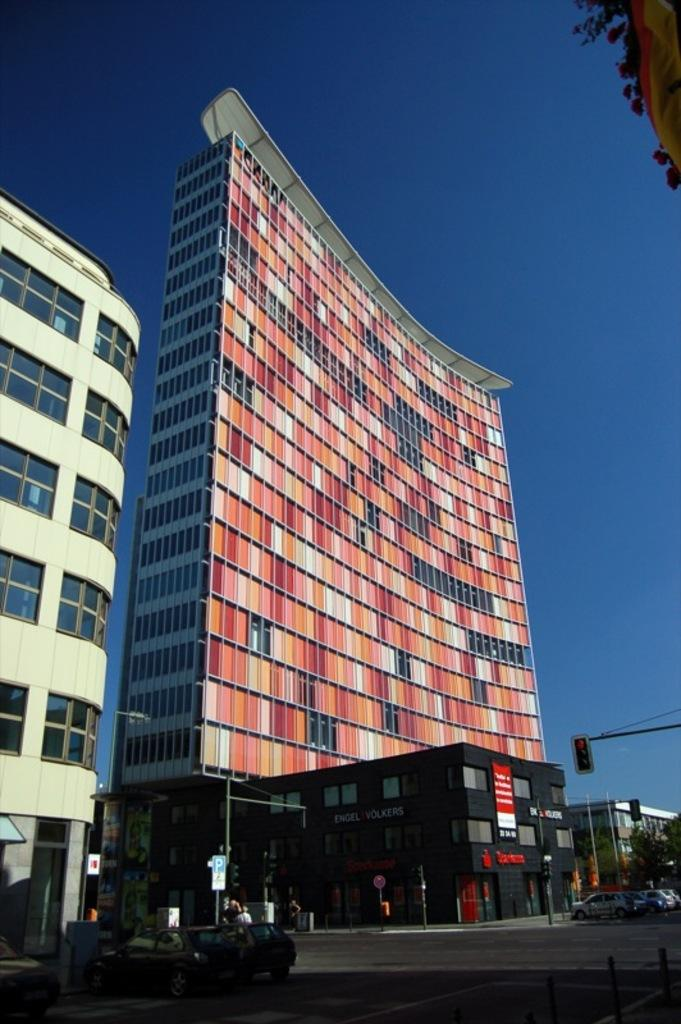What type of structures are visible in the image? There are tower buildings in the image. What can be seen near the tower buildings? There are cars parked in a parking space in the image. Where is the traffic signal pole located in the image? The traffic signal pole is on the bottom right side of the image. What type of list can be seen hanging on the traffic signal pole in the image? There is no list present on the traffic signal pole in the image. 